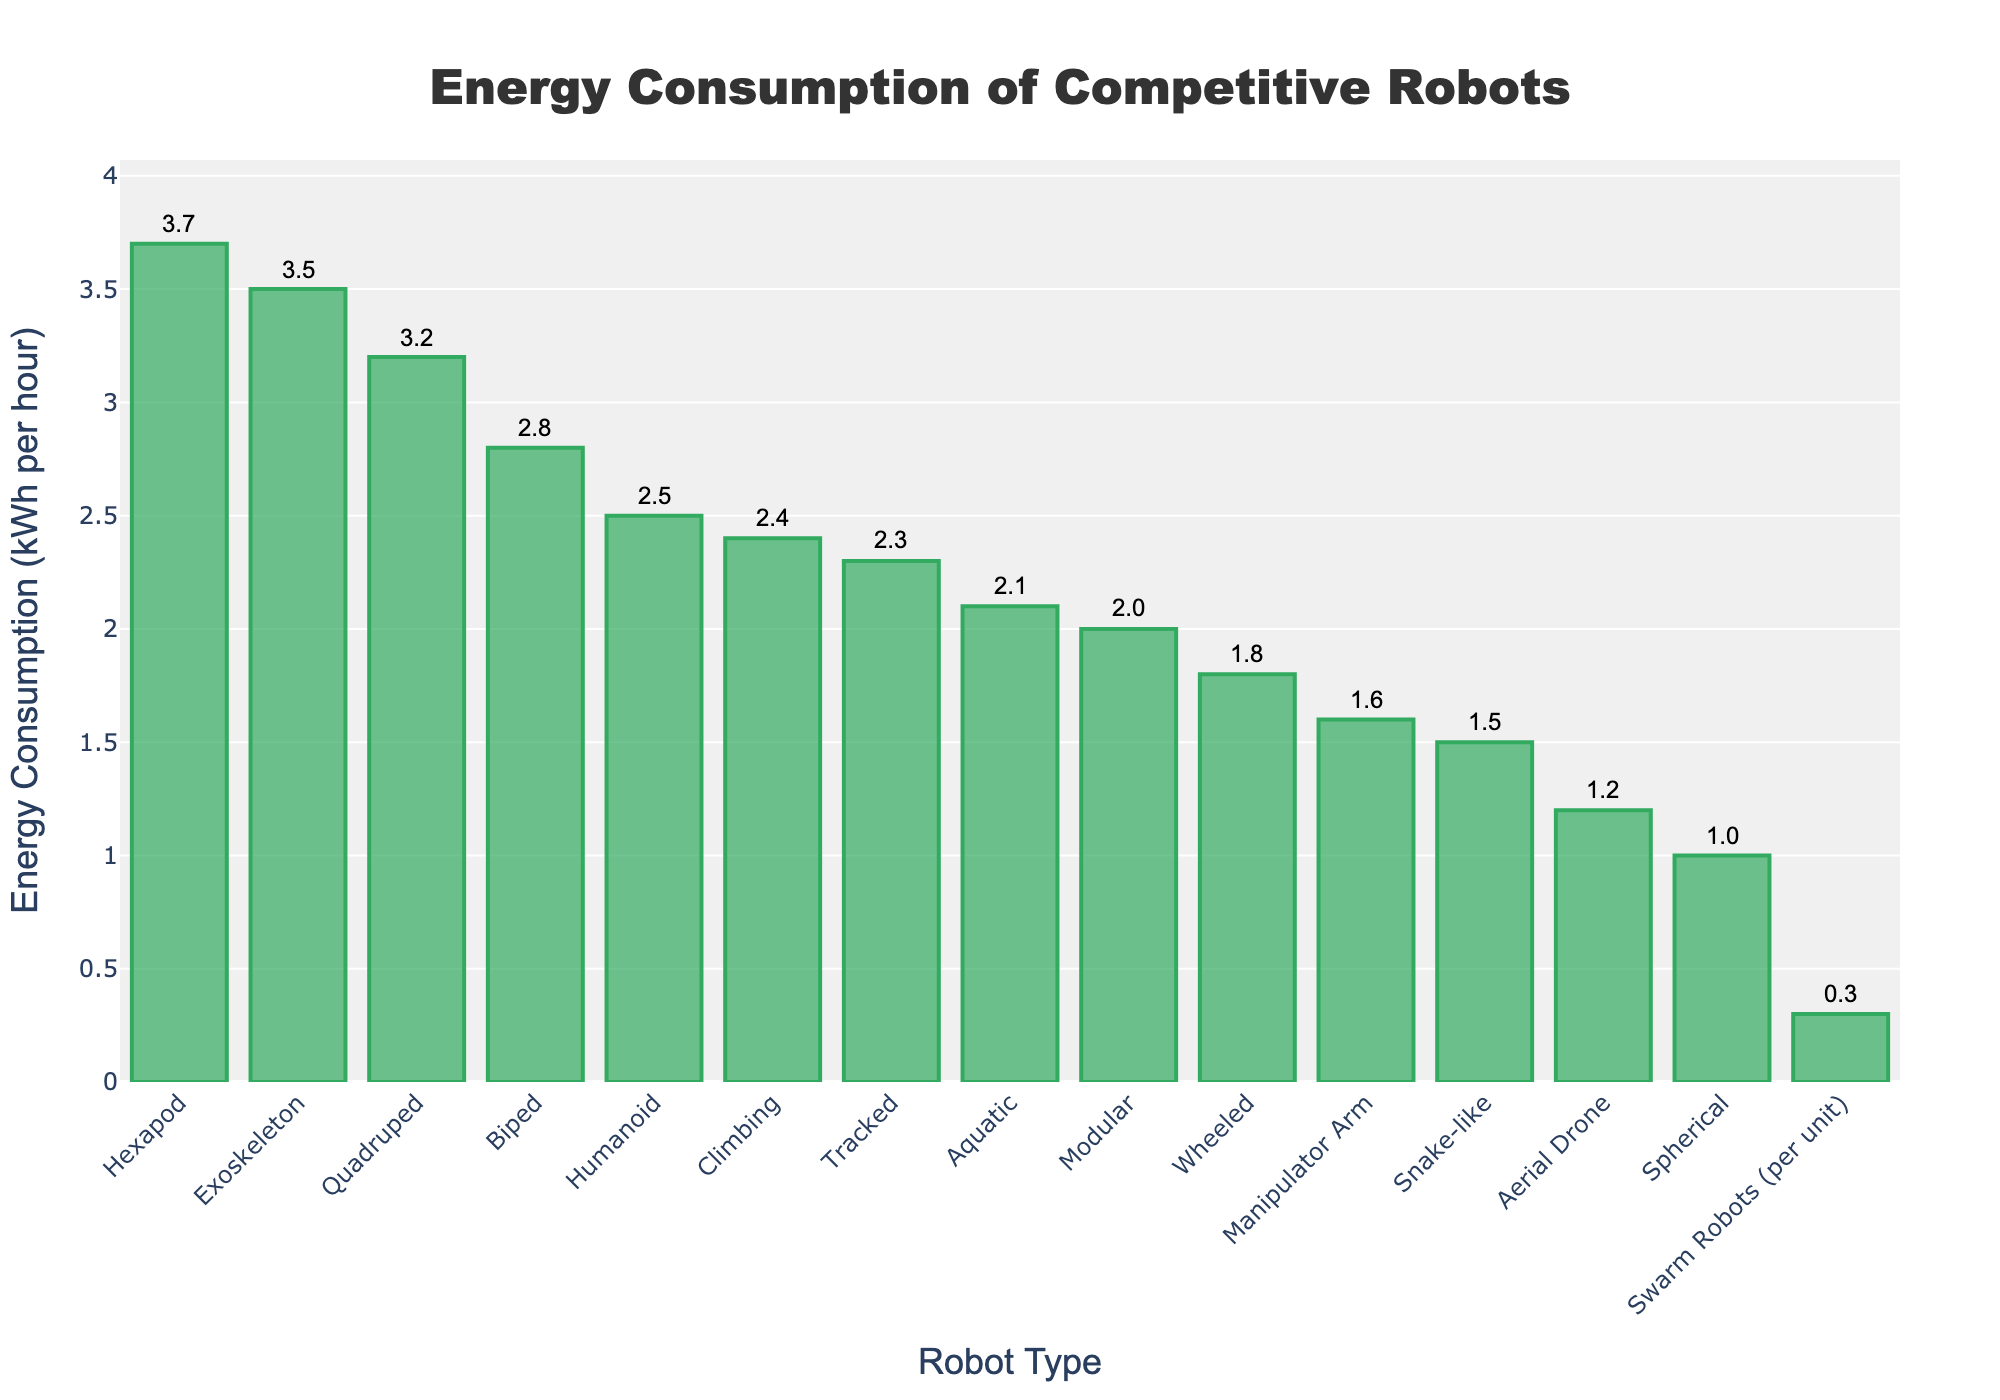What's the type of robot with the highest energy consumption? To determine the type of robot with the highest energy consumption, observe which bar is the tallest in the chart. The tallest bar corresponds to "Hexapod" with an energy consumption of 3.7 kWh per hour.
Answer: Hexapod What is the average energy consumption of the top three energy-consuming robots? First, identify the top three energy-consuming robots: Hexapod (3.7 kWh), Exoskeleton (3.5 kWh), and Quadruped (3.2 kWh). Sum their energy consumption (3.7 + 3.5 + 3.2 = 10.4 kWh) and divide by 3. 10.4 / 3 = 3.47 kWh.
Answer: 3.47 kWh How much more energy does a Hexapod consume compared to a Wheeled robot? Identify the energy consumption values for both robots: Hexapod (3.7 kWh) and Wheeled (1.8 kWh). Subtract the Wheeled's consumption from the Hexapod's: 3.7 - 1.8 = 1.9 kWh.
Answer: 1.9 kWh Which robot type consumes less energy, a Spherical robot or a Swarm Robot unit? Compare the energy consumptions: Spherical (1.0 kWh) and Swarm Robots (per unit 0.3 kWh). Since 0.3 kWh is less than 1.0 kWh, Swarm Robot units consume less energy.
Answer: Swarm Robot unit What is the total energy consumption of all robots combined? Sum up the energy consumptions of all types of robots: 2.5 + 1.8 + 3.2 + 3.7 + 1.2 + 2.1 + 1.5 + 2.8 + 2.3 + 0.3 + 1.6 + 1.0 + 2.0 + 2.4 + 3.5 = 32.9 kWh.
Answer: 32.9 kWh Which robot type has an energy consumption closest to the average energy consumption of all robots? Calculate the average energy consumption: 32.9 kWh / 15 = 2.19 kWh. The closest energy consumption to this value is the Aquatic robot, which consumes 2.1 kWh per hour.
Answer: Aquatic What's the difference in energy consumption between the least consuming and the most consuming robots? The least consuming robot is the Swarm Robots unit (0.3 kWh) and the most consuming robot is the Hexapod (3.7 kWh). Subtract the least from the most: 3.7 - 0.3 = 3.4 kWh.
Answer: 3.4 kWh Rank the following robots by their energy consumption from highest to lowest: Aerial Drone, Manipulator Arm, Climbing, Biped. Identify and compare their energy consumption values: Biped (2.8 kWh), Climbing (2.4 kWh), Manipulator Arm (1.6 kWh), and Aerial Drone (1.2 kWh). Sorted from highest to lowest: Biped, Climbing, Manipulator Arm, Aerial Drone.
Answer: Biped, Climbing, Manipulator Arm, Aerial Drone 